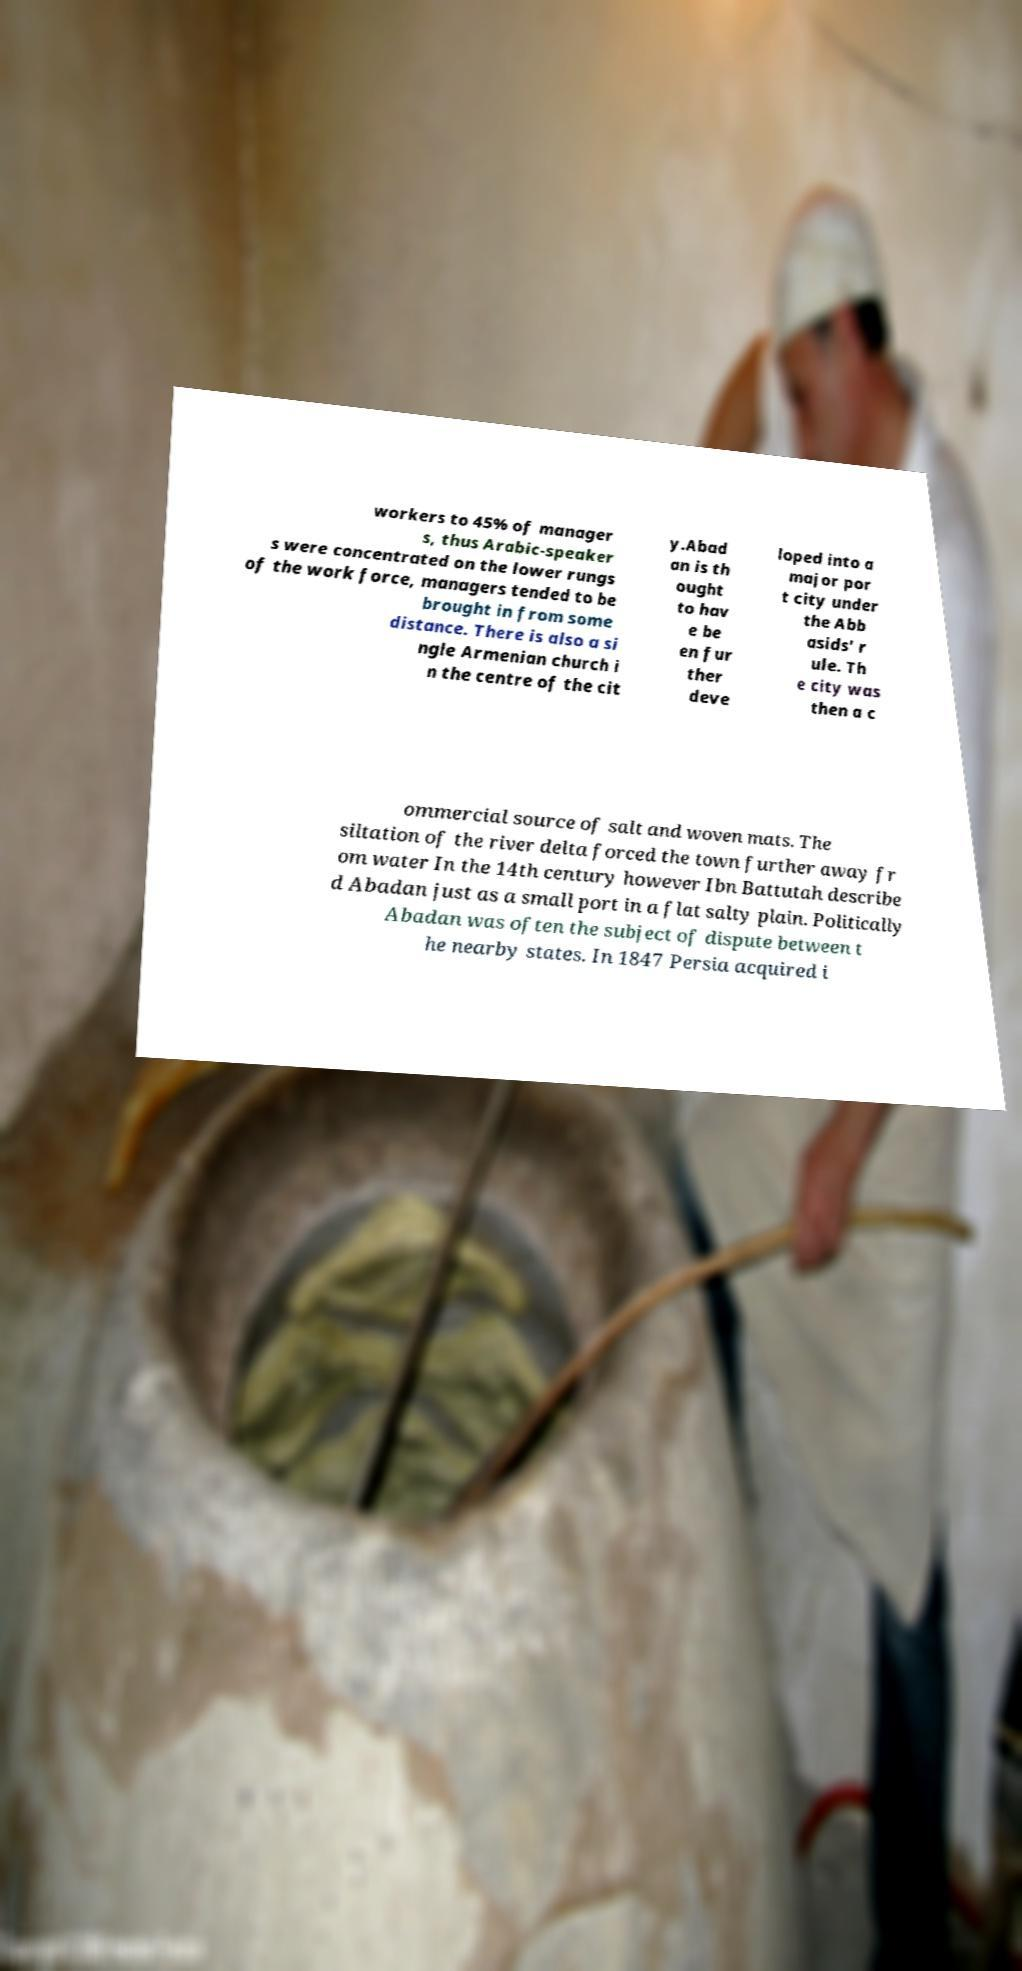Could you extract and type out the text from this image? workers to 45% of manager s, thus Arabic-speaker s were concentrated on the lower rungs of the work force, managers tended to be brought in from some distance. There is also a si ngle Armenian church i n the centre of the cit y.Abad an is th ought to hav e be en fur ther deve loped into a major por t city under the Abb asids' r ule. Th e city was then a c ommercial source of salt and woven mats. The siltation of the river delta forced the town further away fr om water In the 14th century however Ibn Battutah describe d Abadan just as a small port in a flat salty plain. Politically Abadan was often the subject of dispute between t he nearby states. In 1847 Persia acquired i 